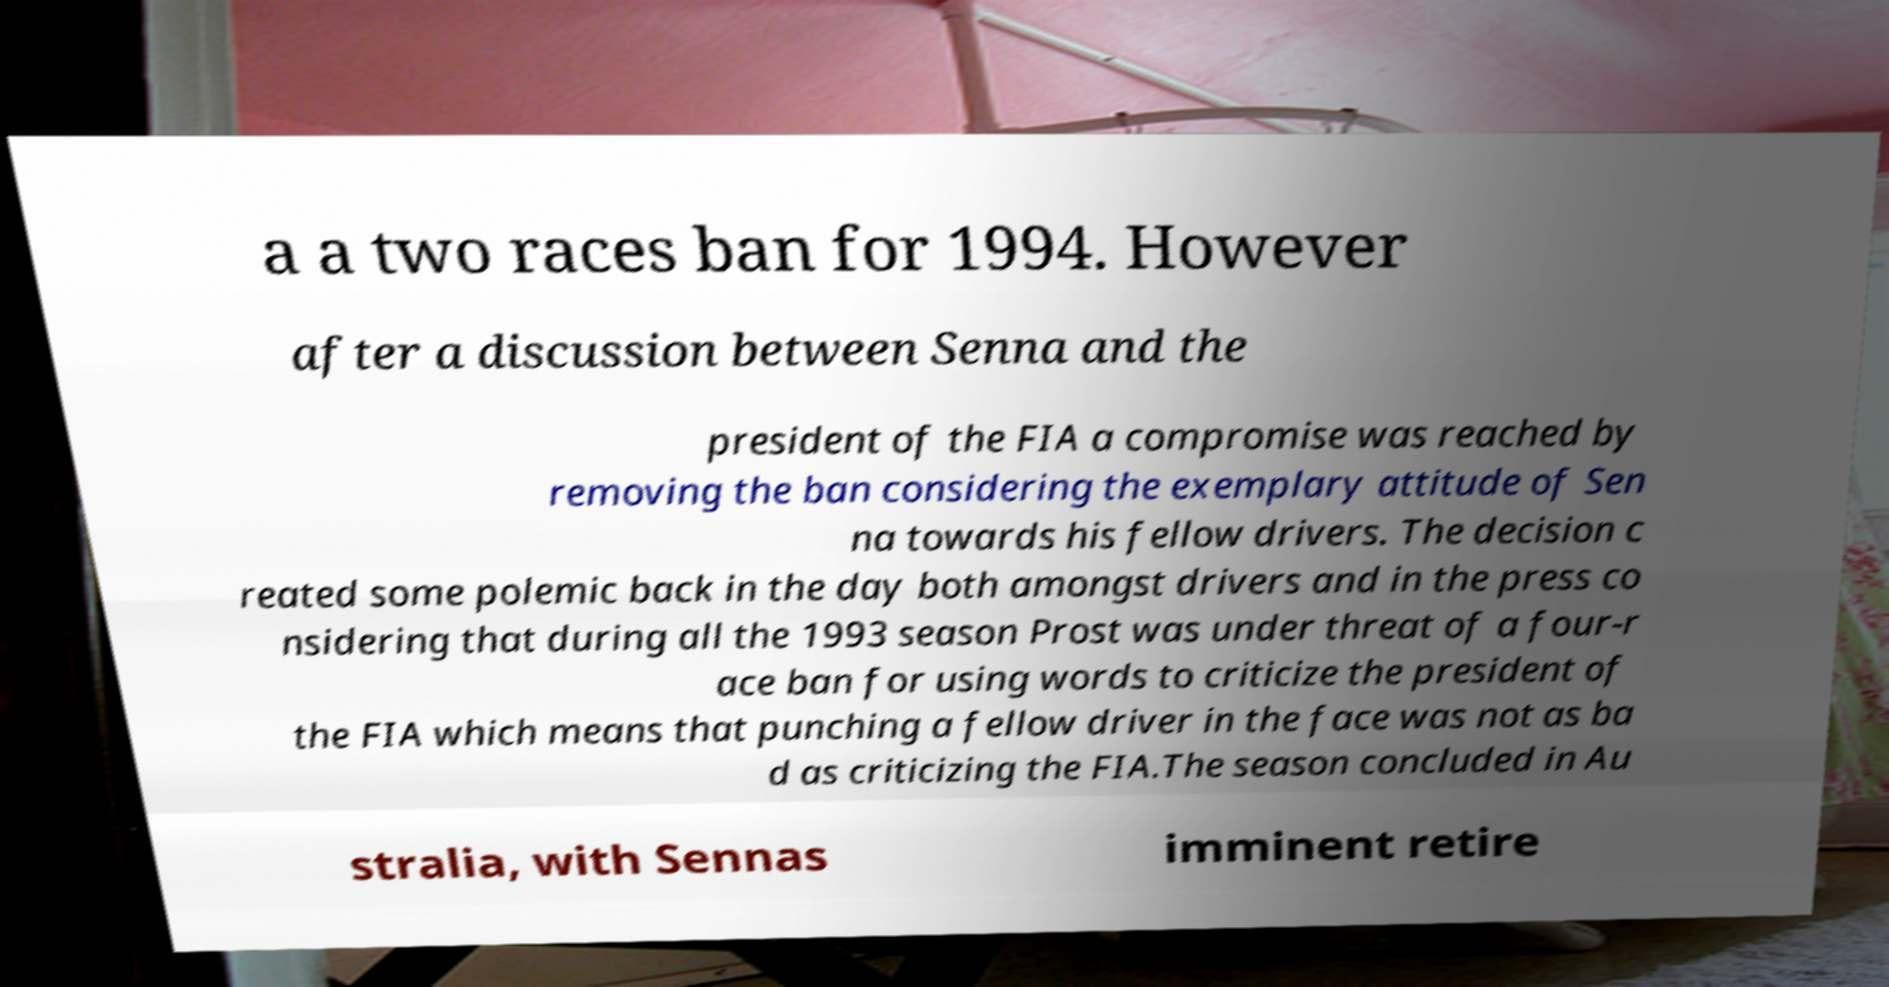Can you accurately transcribe the text from the provided image for me? a a two races ban for 1994. However after a discussion between Senna and the president of the FIA a compromise was reached by removing the ban considering the exemplary attitude of Sen na towards his fellow drivers. The decision c reated some polemic back in the day both amongst drivers and in the press co nsidering that during all the 1993 season Prost was under threat of a four-r ace ban for using words to criticize the president of the FIA which means that punching a fellow driver in the face was not as ba d as criticizing the FIA.The season concluded in Au stralia, with Sennas imminent retire 